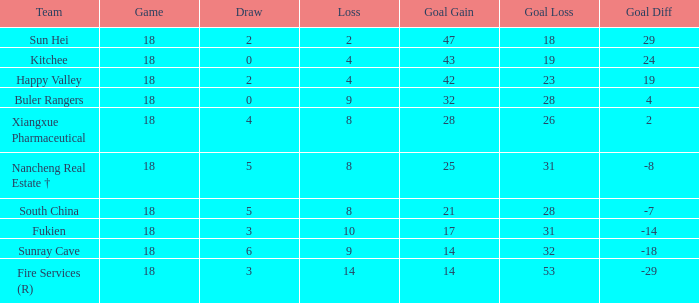What team with a Game smaller than 18 has the lowest Goal Gain? None. Parse the table in full. {'header': ['Team', 'Game', 'Draw', 'Loss', 'Goal Gain', 'Goal Loss', 'Goal Diff'], 'rows': [['Sun Hei', '18', '2', '2', '47', '18', '29'], ['Kitchee', '18', '0', '4', '43', '19', '24'], ['Happy Valley', '18', '2', '4', '42', '23', '19'], ['Buler Rangers', '18', '0', '9', '32', '28', '4'], ['Xiangxue Pharmaceutical', '18', '4', '8', '28', '26', '2'], ['Nancheng Real Estate †', '18', '5', '8', '25', '31', '-8'], ['South China', '18', '5', '8', '21', '28', '-7'], ['Fukien', '18', '3', '10', '17', '31', '-14'], ['Sunray Cave', '18', '6', '9', '14', '32', '-18'], ['Fire Services (R)', '18', '3', '14', '14', '53', '-29']]} 